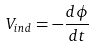Convert formula to latex. <formula><loc_0><loc_0><loc_500><loc_500>V _ { i n d } = - \frac { d \phi } { d t }</formula> 